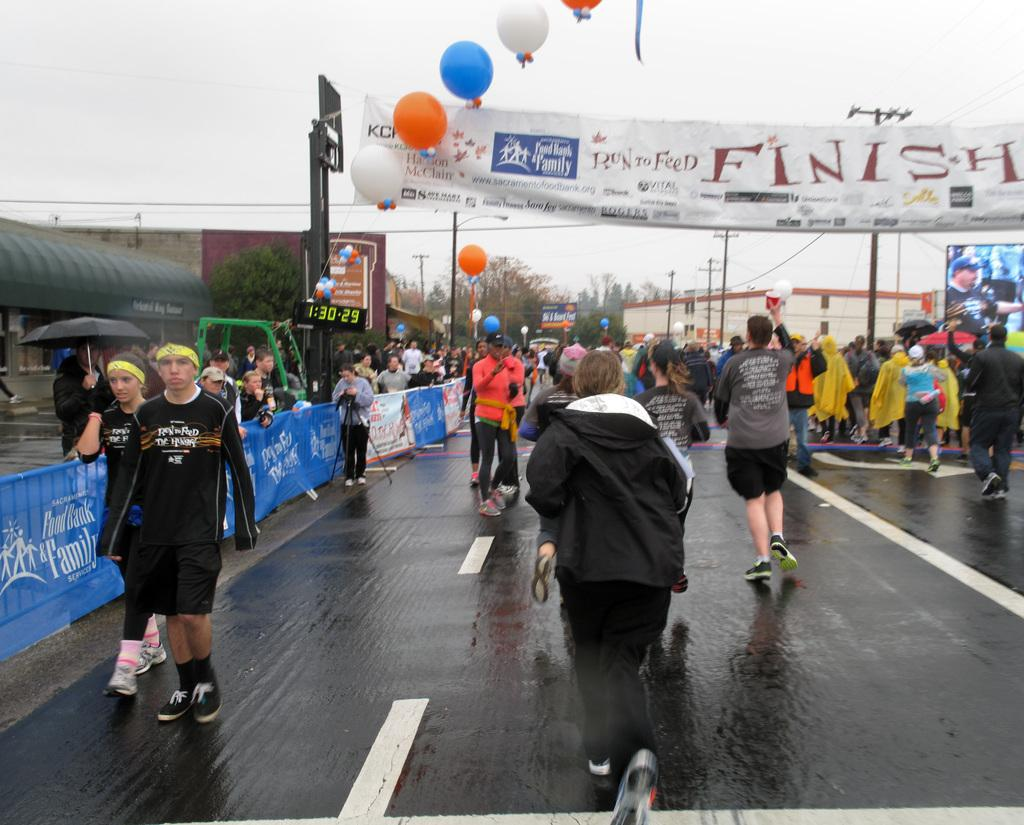What are the people in the image doing? There are people walking on the road in the image. What else can be seen in the image besides the people walking? There is a banner and balloons in the image. What is located beside the road in the image? There are buildings beside the road in the image. What type of vegetation is visible beside the buildings in the image? There are trees beside the buildings in the image. Can you read the note that the deer is holding in the image? There is no note or deer present in the image. How many times does the person in the image sneeze? There is no indication of anyone sneezing in the image. 